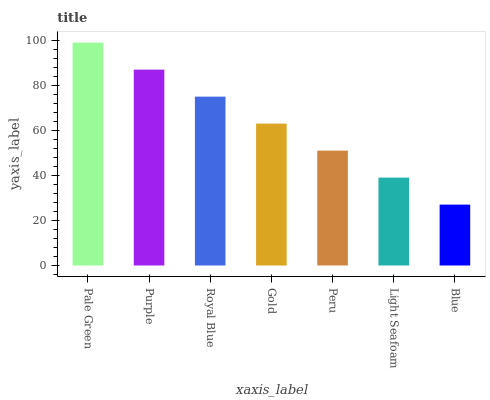Is Blue the minimum?
Answer yes or no. Yes. Is Pale Green the maximum?
Answer yes or no. Yes. Is Purple the minimum?
Answer yes or no. No. Is Purple the maximum?
Answer yes or no. No. Is Pale Green greater than Purple?
Answer yes or no. Yes. Is Purple less than Pale Green?
Answer yes or no. Yes. Is Purple greater than Pale Green?
Answer yes or no. No. Is Pale Green less than Purple?
Answer yes or no. No. Is Gold the high median?
Answer yes or no. Yes. Is Gold the low median?
Answer yes or no. Yes. Is Pale Green the high median?
Answer yes or no. No. Is Purple the low median?
Answer yes or no. No. 